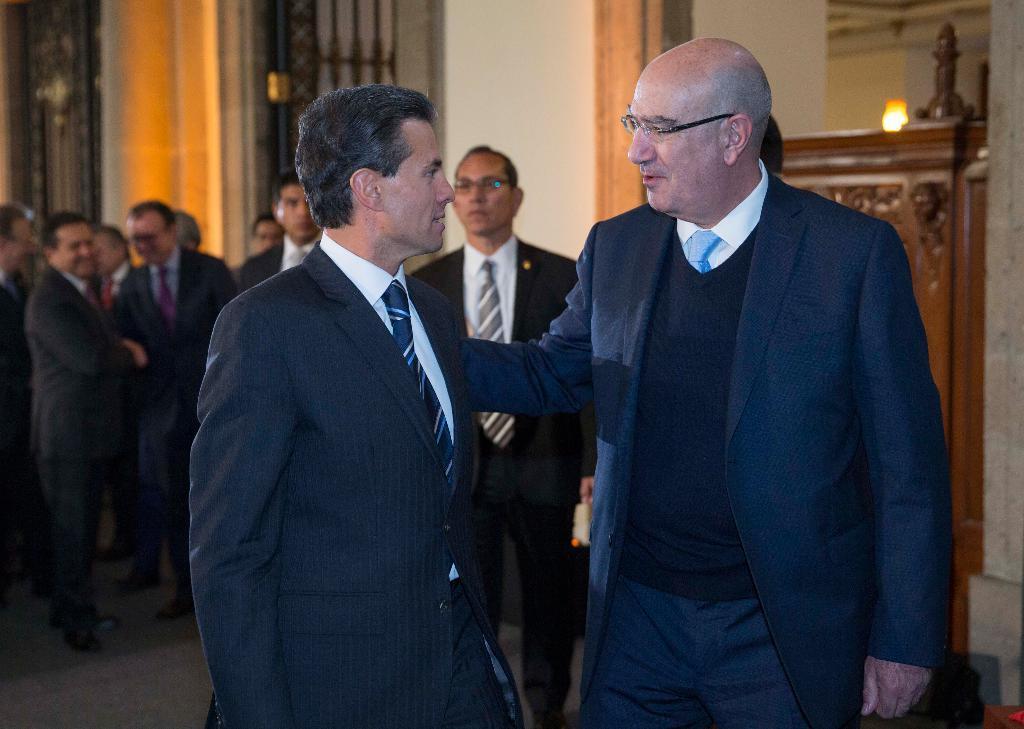How would you summarize this image in a sentence or two? In this picture there are people and we can see floor. In the background of the image we can see wall, light and objects. 